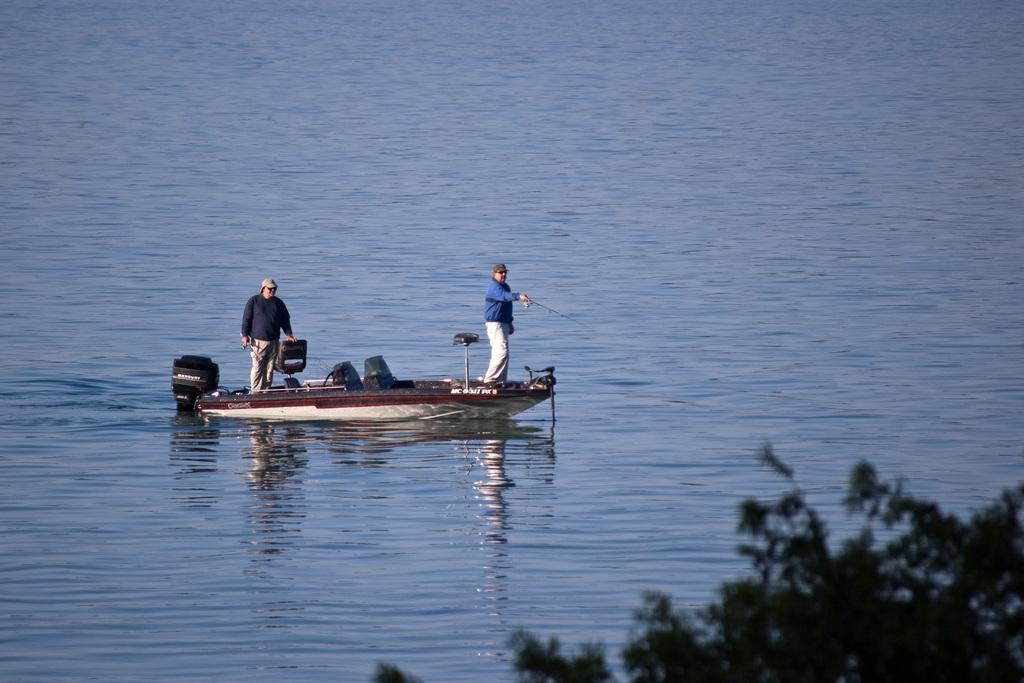What is the main subject of the image? The main subject of the image is a boat. What can be seen in the background of the image? There is water visible in the image. Are there any people present in the image? Yes, there are people on the boat. What type of garden can be seen on the boat in the image? There is no garden present on the boat in the image. How do the people on the boat pull the boat through the water? The image does not show any method of propulsion for the boat, so it cannot be determined how the people are moving the boat. 